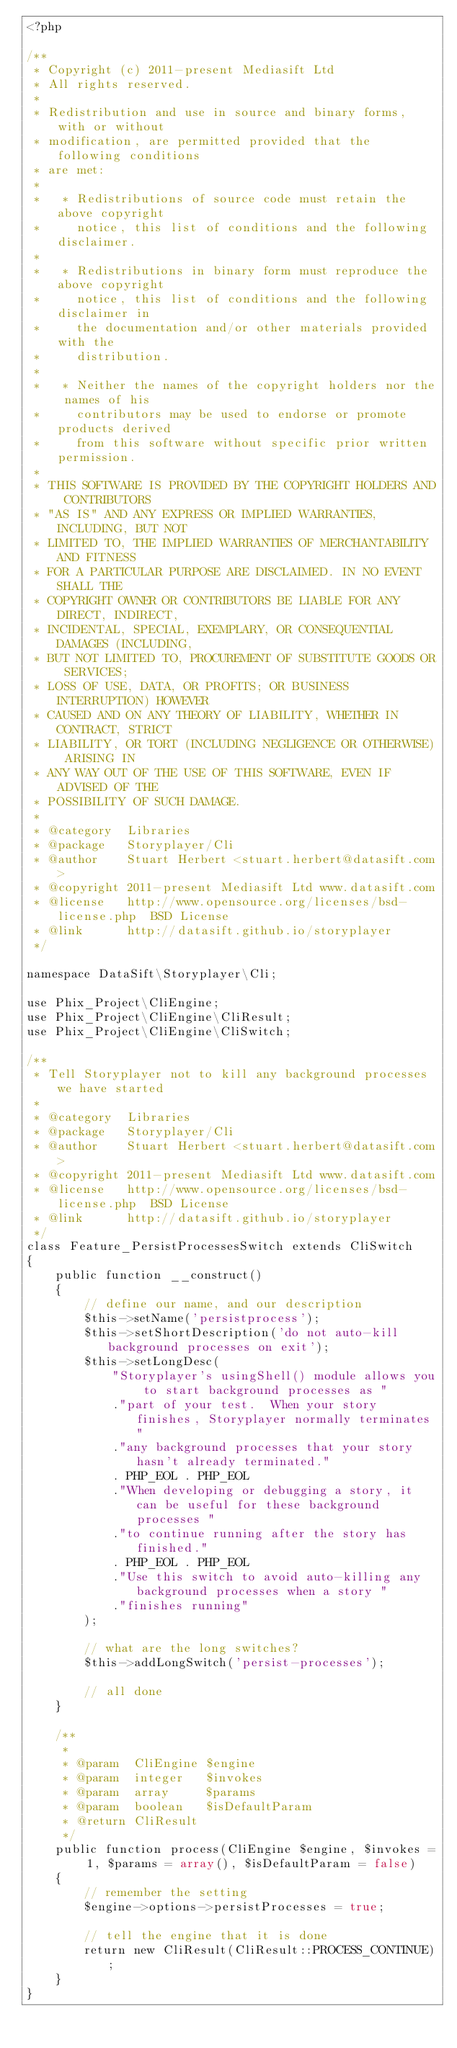<code> <loc_0><loc_0><loc_500><loc_500><_PHP_><?php

/**
 * Copyright (c) 2011-present Mediasift Ltd
 * All rights reserved.
 *
 * Redistribution and use in source and binary forms, with or without
 * modification, are permitted provided that the following conditions
 * are met:
 *
 *   * Redistributions of source code must retain the above copyright
 *     notice, this list of conditions and the following disclaimer.
 *
 *   * Redistributions in binary form must reproduce the above copyright
 *     notice, this list of conditions and the following disclaimer in
 *     the documentation and/or other materials provided with the
 *     distribution.
 *
 *   * Neither the names of the copyright holders nor the names of his
 *     contributors may be used to endorse or promote products derived
 *     from this software without specific prior written permission.
 *
 * THIS SOFTWARE IS PROVIDED BY THE COPYRIGHT HOLDERS AND CONTRIBUTORS
 * "AS IS" AND ANY EXPRESS OR IMPLIED WARRANTIES, INCLUDING, BUT NOT
 * LIMITED TO, THE IMPLIED WARRANTIES OF MERCHANTABILITY AND FITNESS
 * FOR A PARTICULAR PURPOSE ARE DISCLAIMED. IN NO EVENT SHALL THE
 * COPYRIGHT OWNER OR CONTRIBUTORS BE LIABLE FOR ANY DIRECT, INDIRECT,
 * INCIDENTAL, SPECIAL, EXEMPLARY, OR CONSEQUENTIAL DAMAGES (INCLUDING,
 * BUT NOT LIMITED TO, PROCUREMENT OF SUBSTITUTE GOODS OR SERVICES;
 * LOSS OF USE, DATA, OR PROFITS; OR BUSINESS INTERRUPTION) HOWEVER
 * CAUSED AND ON ANY THEORY OF LIABILITY, WHETHER IN CONTRACT, STRICT
 * LIABILITY, OR TORT (INCLUDING NEGLIGENCE OR OTHERWISE) ARISING IN
 * ANY WAY OUT OF THE USE OF THIS SOFTWARE, EVEN IF ADVISED OF THE
 * POSSIBILITY OF SUCH DAMAGE.
 *
 * @category  Libraries
 * @package   Storyplayer/Cli
 * @author    Stuart Herbert <stuart.herbert@datasift.com>
 * @copyright 2011-present Mediasift Ltd www.datasift.com
 * @license   http://www.opensource.org/licenses/bsd-license.php  BSD License
 * @link      http://datasift.github.io/storyplayer
 */

namespace DataSift\Storyplayer\Cli;

use Phix_Project\CliEngine;
use Phix_Project\CliEngine\CliResult;
use Phix_Project\CliEngine\CliSwitch;

/**
 * Tell Storyplayer not to kill any background processes we have started
 *
 * @category  Libraries
 * @package   Storyplayer/Cli
 * @author    Stuart Herbert <stuart.herbert@datasift.com>
 * @copyright 2011-present Mediasift Ltd www.datasift.com
 * @license   http://www.opensource.org/licenses/bsd-license.php  BSD License
 * @link      http://datasift.github.io/storyplayer
 */
class Feature_PersistProcessesSwitch extends CliSwitch
{
    public function __construct()
    {
        // define our name, and our description
        $this->setName('persistprocess');
        $this->setShortDescription('do not auto-kill background processes on exit');
        $this->setLongDesc(
            "Storyplayer's usingShell() module allows you to start background processes as "
            ."part of your test.  When your story finishes, Storyplayer normally terminates "
            ."any background processes that your story hasn't already terminated."
            . PHP_EOL . PHP_EOL
            ."When developing or debugging a story, it can be useful for these background processes "
            ."to continue running after the story has finished."
            . PHP_EOL . PHP_EOL
            ."Use this switch to avoid auto-killing any background processes when a story "
            ."finishes running"
        );

        // what are the long switches?
        $this->addLongSwitch('persist-processes');

        // all done
    }

    /**
     *
     * @param  CliEngine $engine
     * @param  integer   $invokes
     * @param  array     $params
     * @param  boolean   $isDefaultParam
     * @return CliResult
     */
    public function process(CliEngine $engine, $invokes = 1, $params = array(), $isDefaultParam = false)
    {
        // remember the setting
        $engine->options->persistProcesses = true;

        // tell the engine that it is done
        return new CliResult(CliResult::PROCESS_CONTINUE);
    }
}</code> 